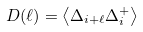Convert formula to latex. <formula><loc_0><loc_0><loc_500><loc_500>D ( \ell ) = \left \langle \Delta _ { i + \ell } \Delta ^ { + } _ { i } \right \rangle</formula> 